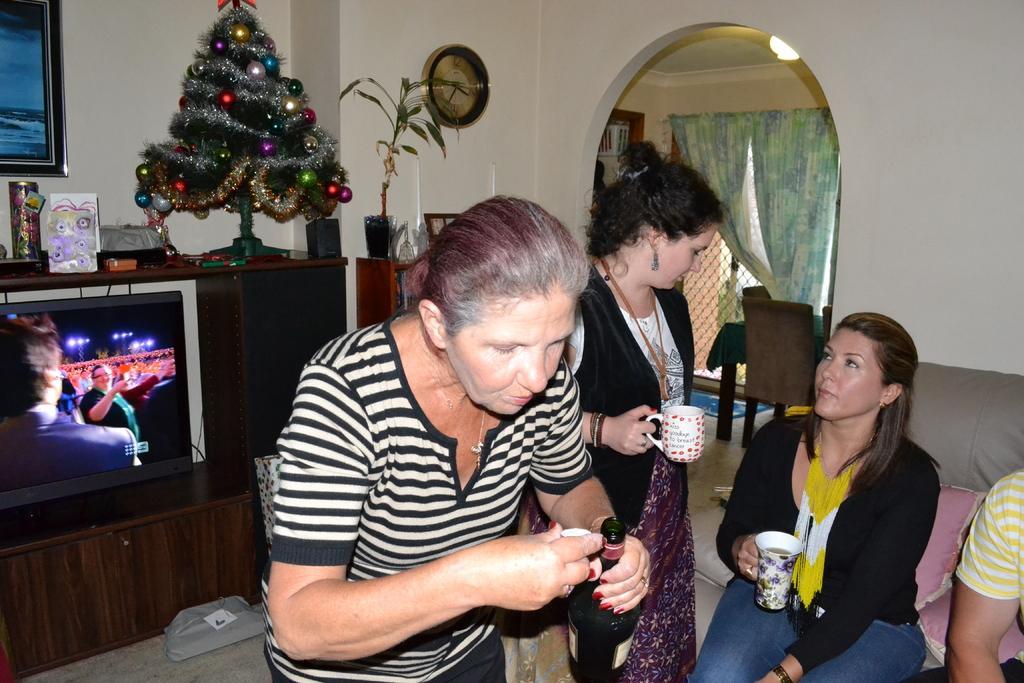In one or two sentences, can you explain what this image depicts? In this image there are four person. The woman is holding the bottle another woman is holding a cup. There is a clock on a wall and a Christmas tree. There is a television and the backside there are curtain,chair and a table in the room. 